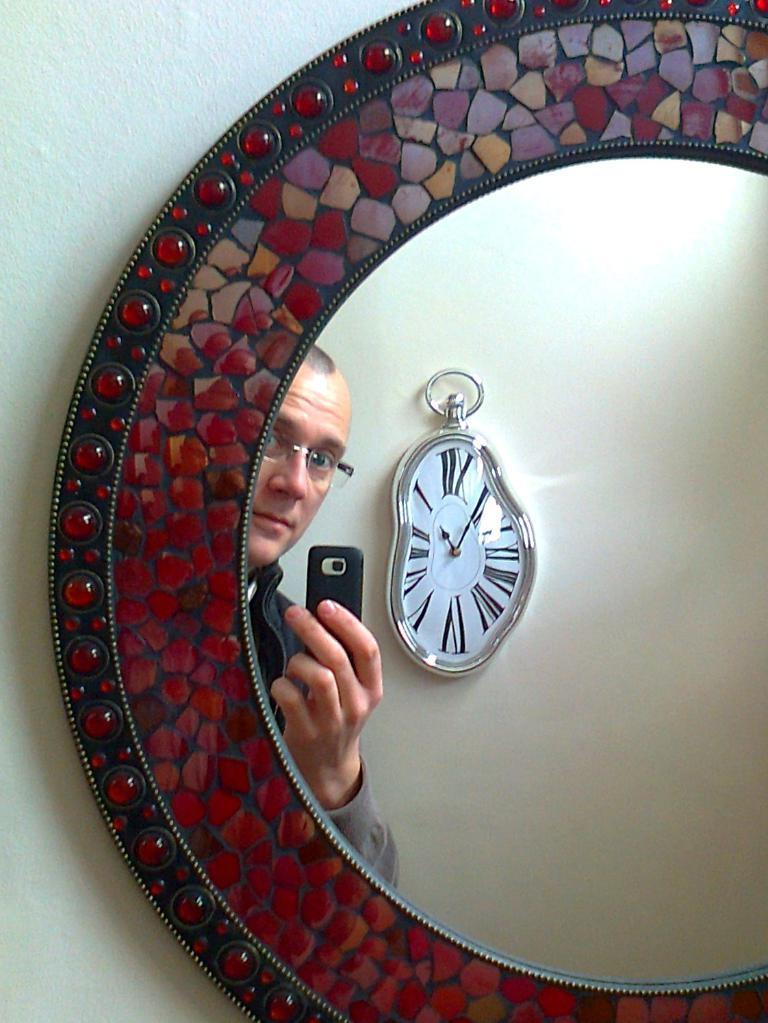Please provide a concise description of this image. In this picture I can see a mirror on the wall and I can see reflection of a wall clock and a man holding a mobile in his hand in the mirror. 